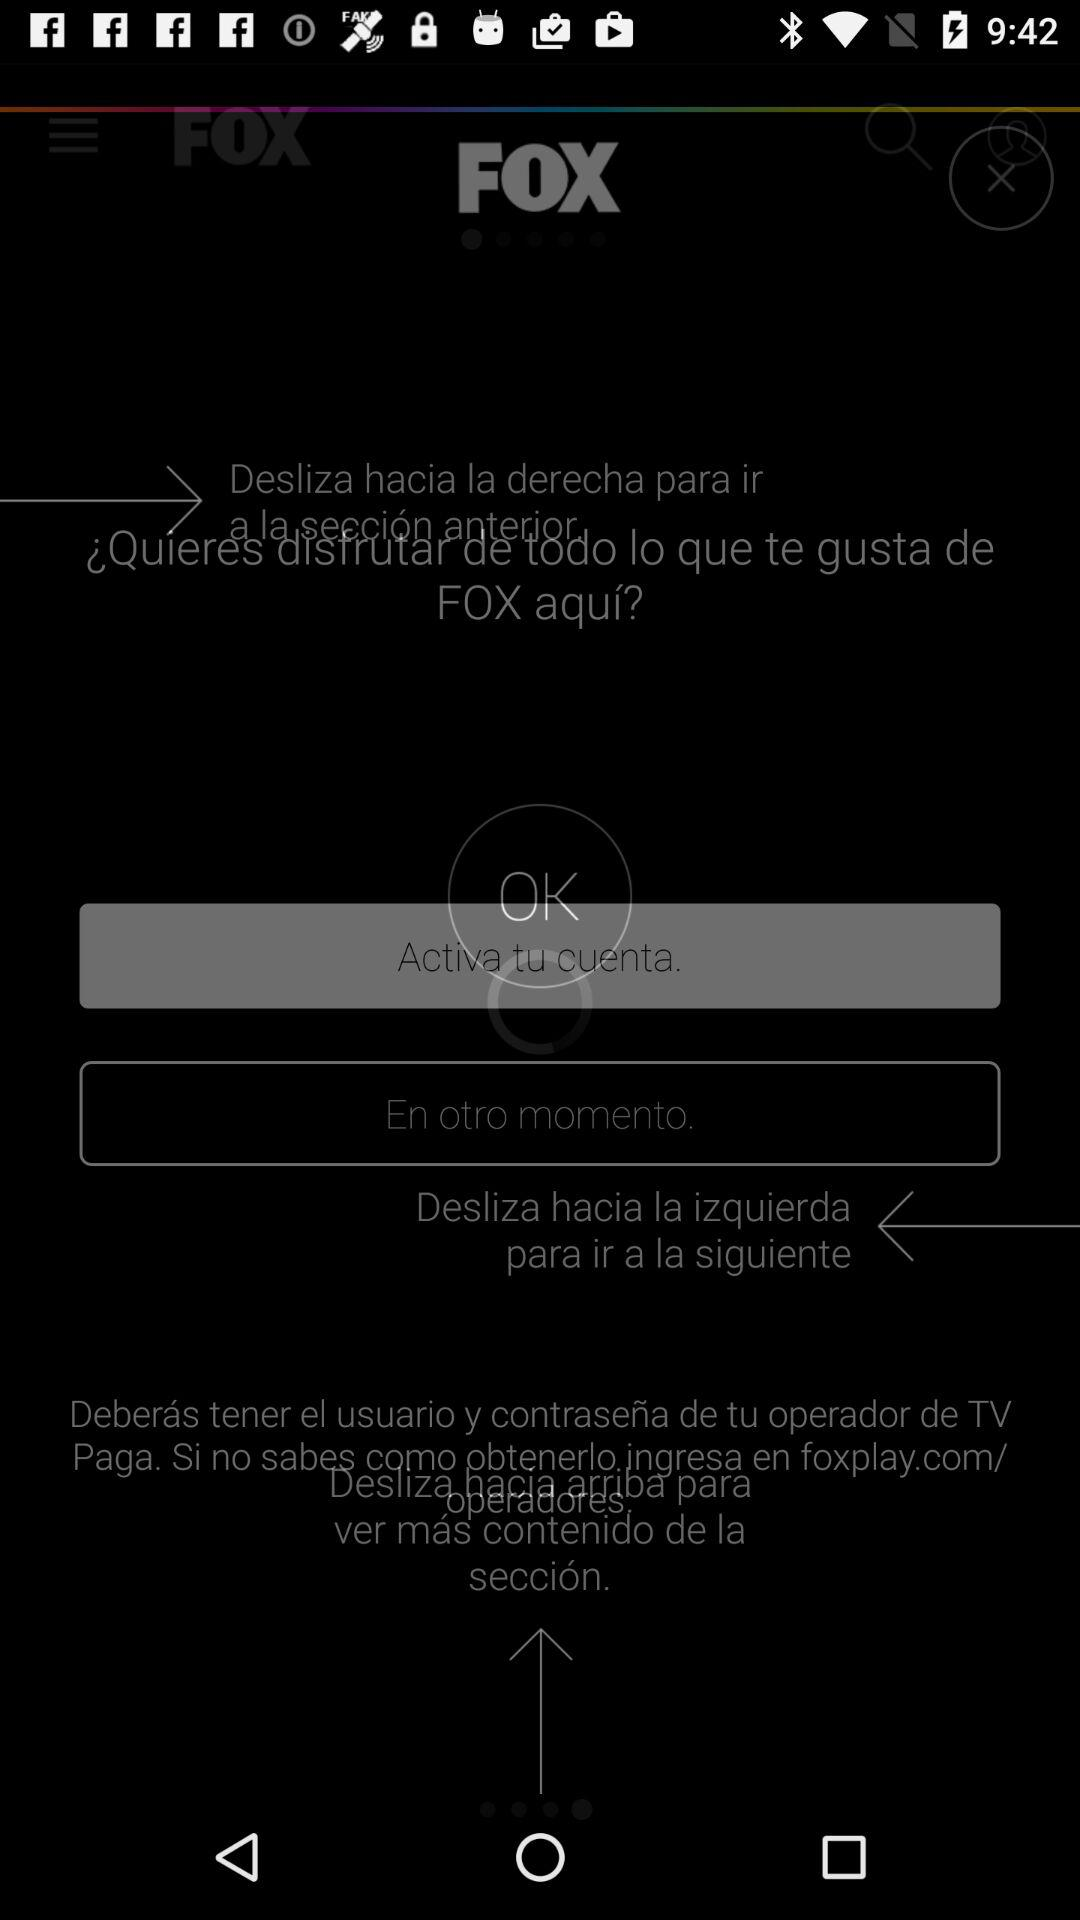What is the application name? The application name is "FOX". 